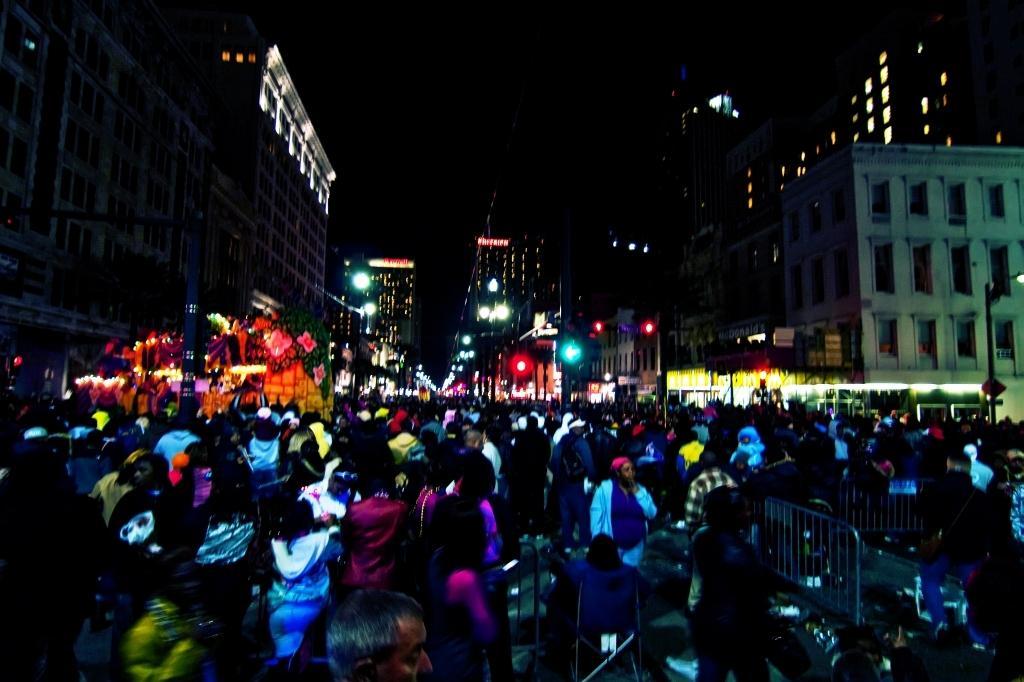Please provide a concise description of this image. This picture is taken in the dark where we can see these people on the road. Here we can see barrier gates, buildings, light poles and the dark sky in the background. 